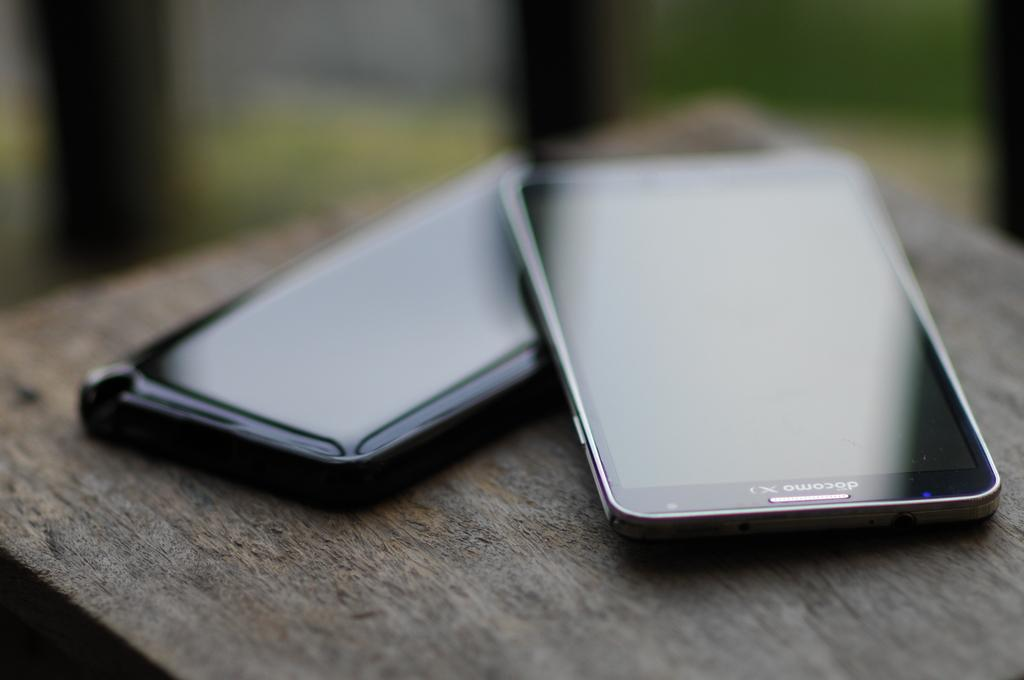<image>
Render a clear and concise summary of the photo. Two black docomo phones placed on top of one another. 